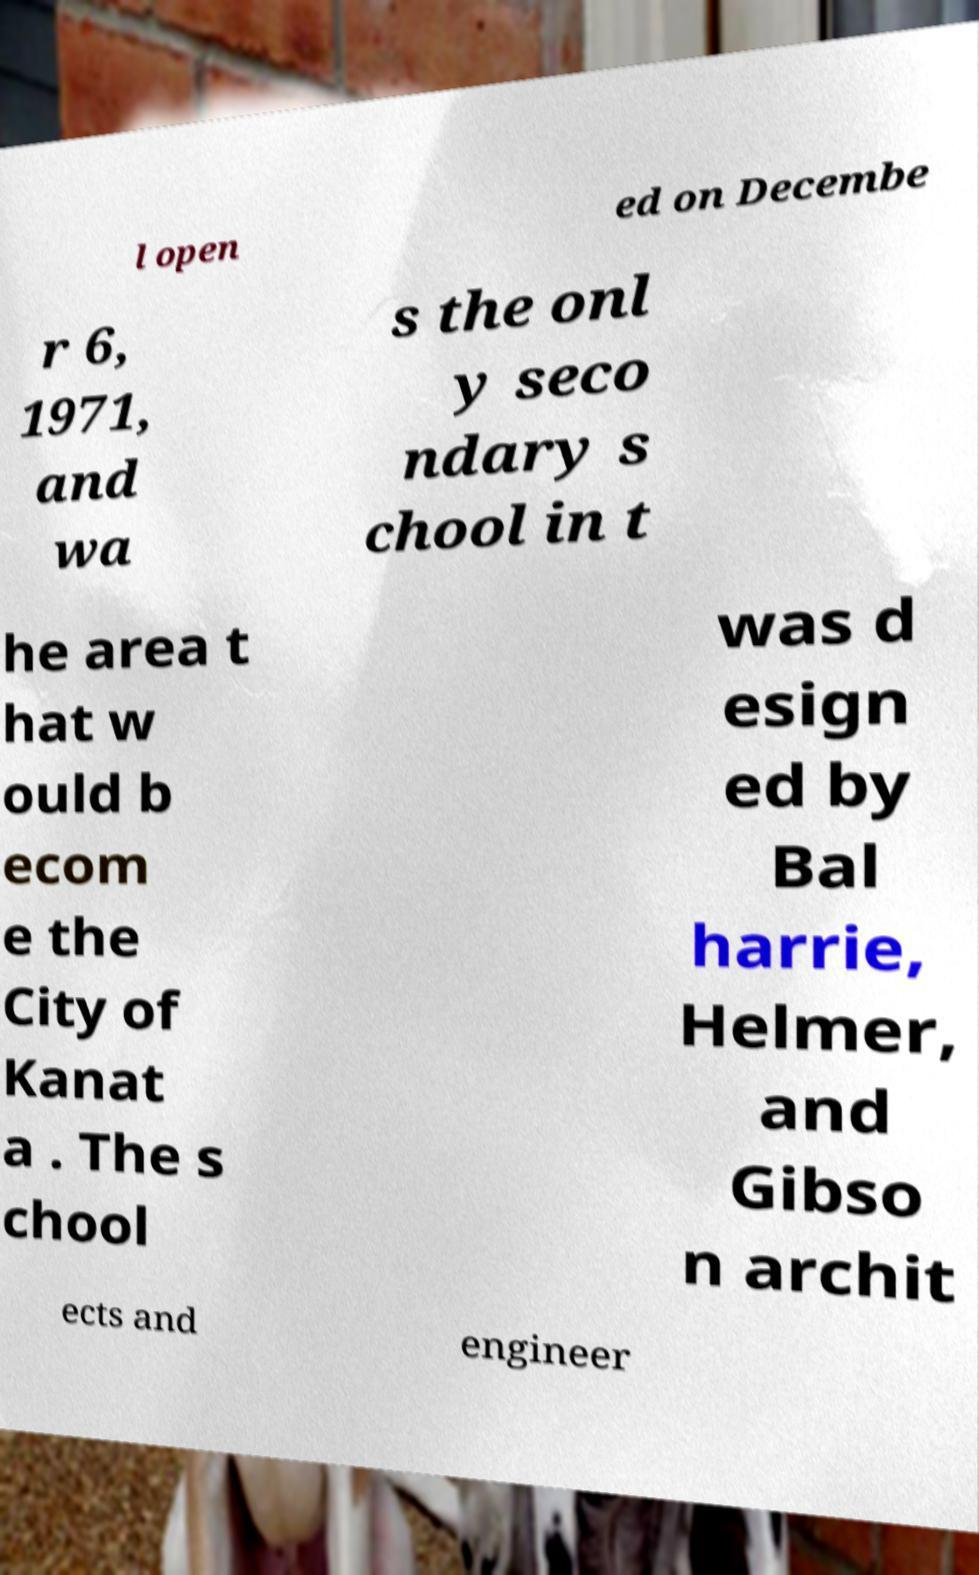Can you accurately transcribe the text from the provided image for me? l open ed on Decembe r 6, 1971, and wa s the onl y seco ndary s chool in t he area t hat w ould b ecom e the City of Kanat a . The s chool was d esign ed by Bal harrie, Helmer, and Gibso n archit ects and engineer 